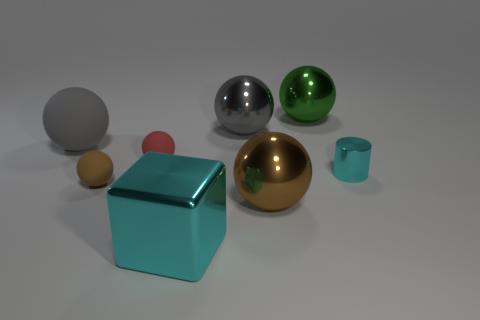Subtract 2 balls. How many balls are left? 4 Subtract all big gray balls. How many balls are left? 4 Subtract all gray balls. How many balls are left? 4 Add 1 red cubes. How many objects exist? 9 Subtract all yellow spheres. Subtract all brown cubes. How many spheres are left? 6 Subtract all blocks. How many objects are left? 7 Subtract all tiny brown spheres. Subtract all big gray objects. How many objects are left? 5 Add 6 cylinders. How many cylinders are left? 7 Add 1 big green balls. How many big green balls exist? 2 Subtract 0 red blocks. How many objects are left? 8 